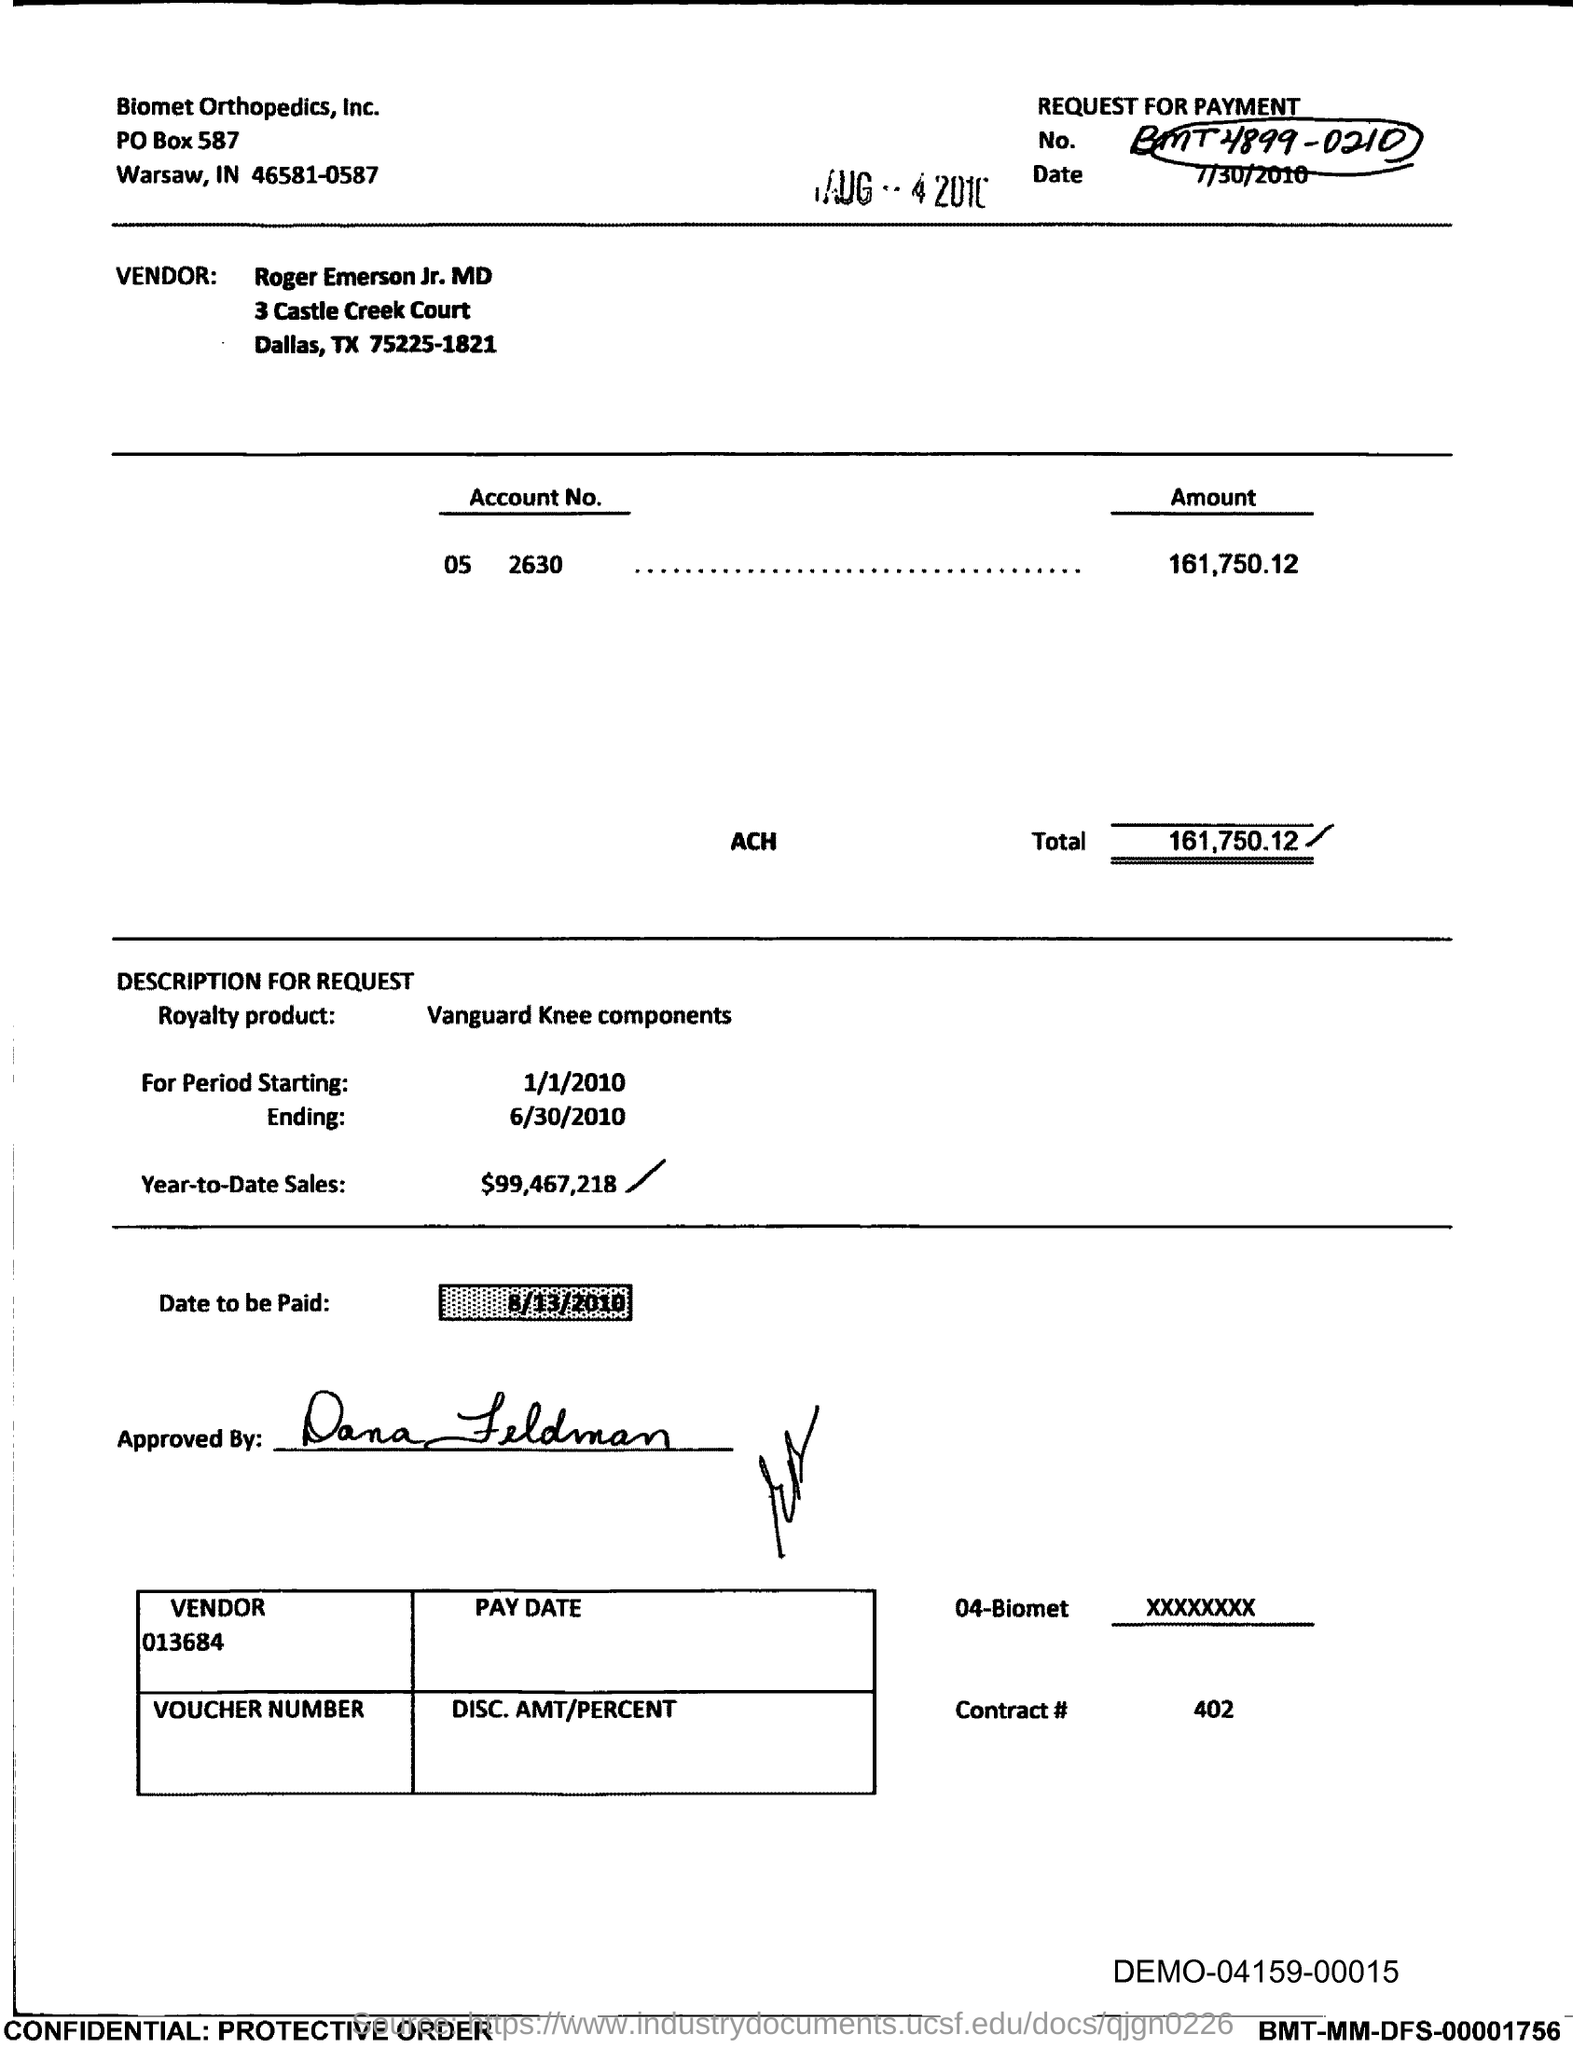Specify some key components in this picture. The vendor is Roger Emerson Jr., MD. The date is July 30, 2010. The starting period is from 1/1/2010. What is the ending period of 6/30/2010? The year-to-date sales as of today are $99,467,218. 